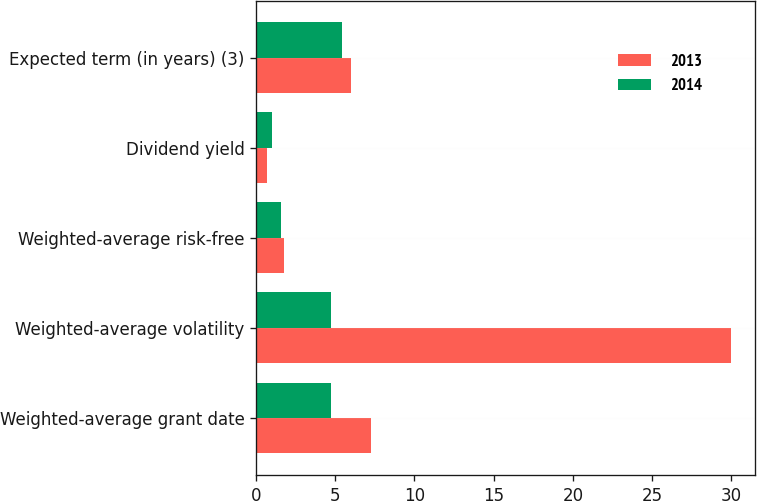Convert chart. <chart><loc_0><loc_0><loc_500><loc_500><stacked_bar_chart><ecel><fcel>Weighted-average grant date<fcel>Weighted-average volatility<fcel>Weighted-average risk-free<fcel>Dividend yield<fcel>Expected term (in years) (3)<nl><fcel>2013<fcel>7.23<fcel>30<fcel>1.77<fcel>0.7<fcel>6<nl><fcel>2014<fcel>4.75<fcel>4.75<fcel>1.58<fcel>1<fcel>5.4<nl></chart> 